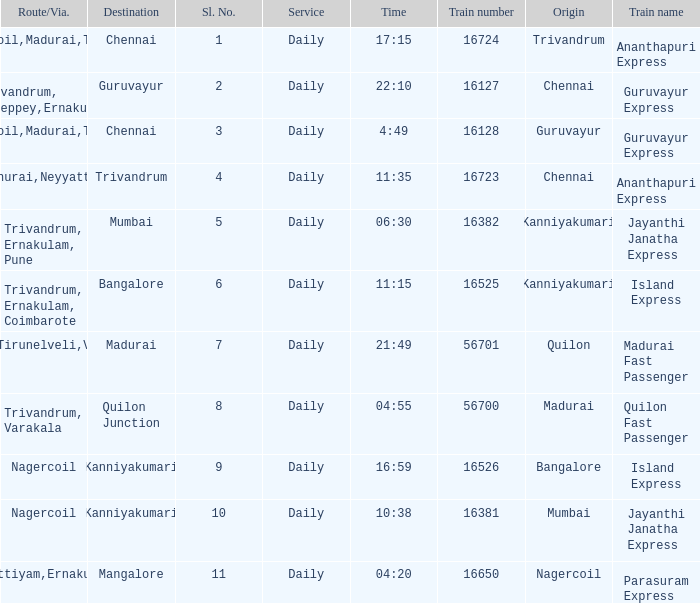What is the destination when the train number is 16526? Kanniyakumari. 